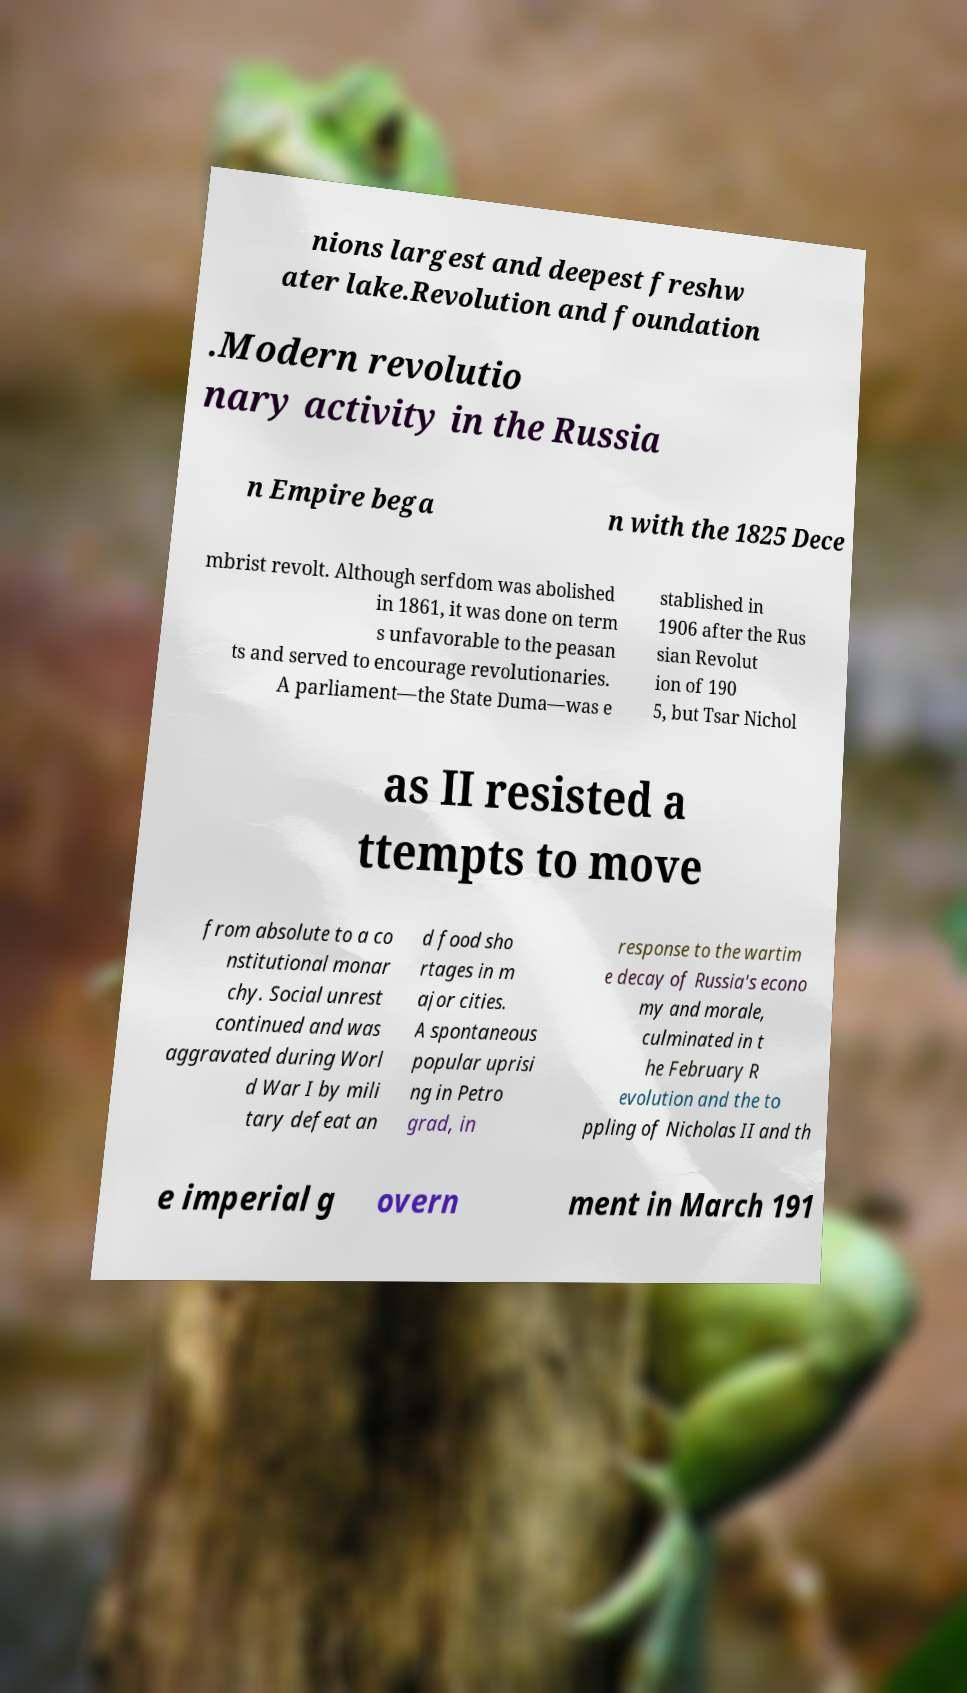Could you assist in decoding the text presented in this image and type it out clearly? nions largest and deepest freshw ater lake.Revolution and foundation .Modern revolutio nary activity in the Russia n Empire bega n with the 1825 Dece mbrist revolt. Although serfdom was abolished in 1861, it was done on term s unfavorable to the peasan ts and served to encourage revolutionaries. A parliament—the State Duma—was e stablished in 1906 after the Rus sian Revolut ion of 190 5, but Tsar Nichol as II resisted a ttempts to move from absolute to a co nstitutional monar chy. Social unrest continued and was aggravated during Worl d War I by mili tary defeat an d food sho rtages in m ajor cities. A spontaneous popular uprisi ng in Petro grad, in response to the wartim e decay of Russia's econo my and morale, culminated in t he February R evolution and the to ppling of Nicholas II and th e imperial g overn ment in March 191 